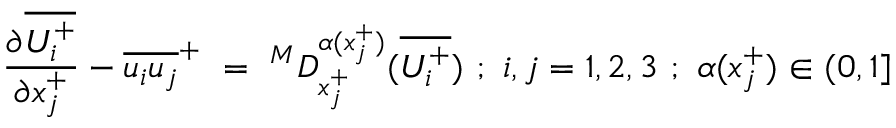<formula> <loc_0><loc_0><loc_500><loc_500>\frac { \partial \overline { { U _ { i } ^ { + } } } } { \partial x _ { j } ^ { + } } - \overline { { u _ { i } u _ { j } } } ^ { + } = ^ { M } D _ { x _ { j } ^ { + } } ^ { \alpha ( x _ { j } ^ { + } ) } ( \overline { { U _ { i } ^ { + } } } ) ; i , j = 1 , 2 , 3 ; \alpha ( x _ { j } ^ { + } ) \in ( 0 , 1 ]</formula> 